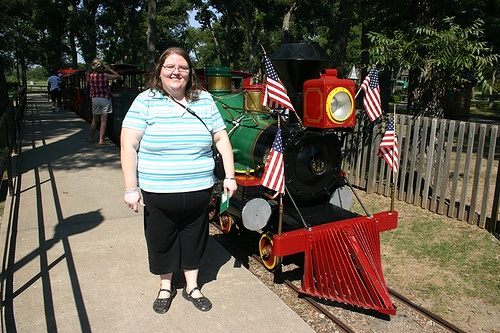Describe the objects in this image and their specific colors. I can see train in black, brown, maroon, and darkgray tones, people in black, white, lightblue, and lightpink tones, people in black, gray, and maroon tones, handbag in black, gray, darkgray, and teal tones, and people in black, blue, navy, and gray tones in this image. 